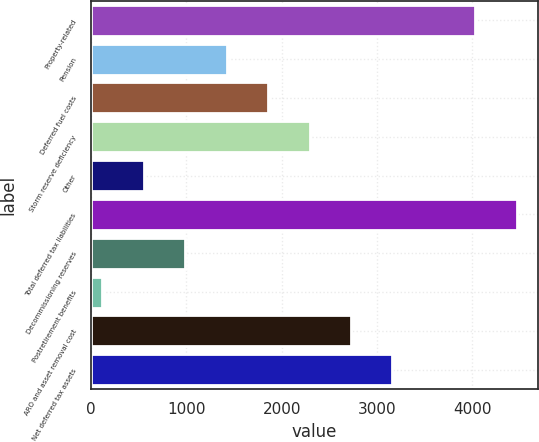<chart> <loc_0><loc_0><loc_500><loc_500><bar_chart><fcel>Property-related<fcel>Pension<fcel>Deferred fuel costs<fcel>Storm reserve deficiency<fcel>Other<fcel>Total deferred tax liabilities<fcel>Decommissioning reserves<fcel>Postretirement benefits<fcel>ARO and asset removal cost<fcel>Net deferred tax assets<nl><fcel>4030.5<fcel>1423.5<fcel>1858<fcel>2292.5<fcel>554.5<fcel>4465<fcel>989<fcel>120<fcel>2727<fcel>3161.5<nl></chart> 